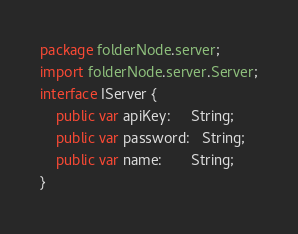Convert code to text. <code><loc_0><loc_0><loc_500><loc_500><_Haxe_>package folderNode.server;
import folderNode.server.Server;
interface IServer {
    public var apiKey:     String;
    public var password:   String;
    public var name:       String;
}</code> 